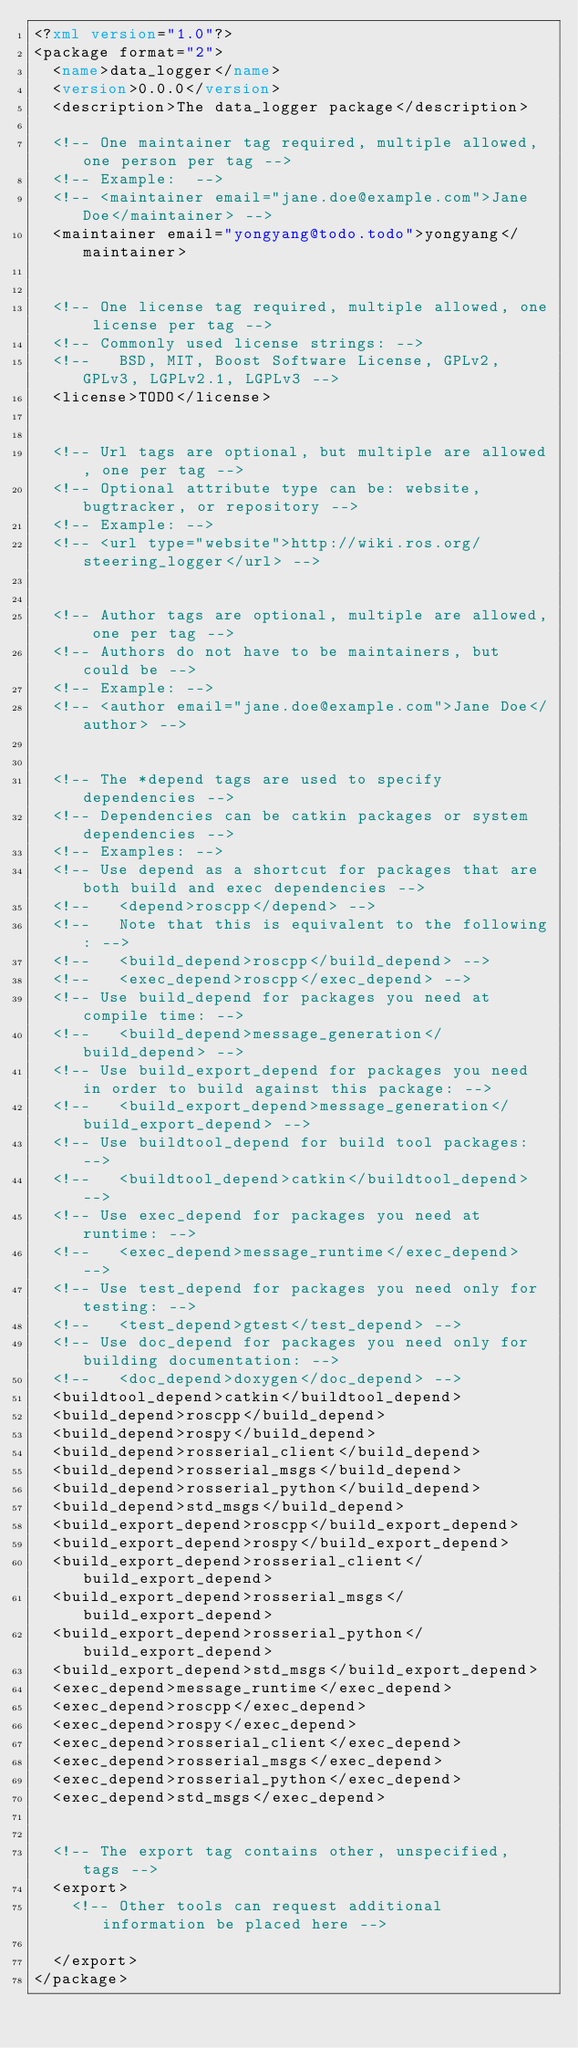<code> <loc_0><loc_0><loc_500><loc_500><_XML_><?xml version="1.0"?>
<package format="2">
  <name>data_logger</name>
  <version>0.0.0</version>
  <description>The data_logger package</description>

  <!-- One maintainer tag required, multiple allowed, one person per tag -->
  <!-- Example:  -->
  <!-- <maintainer email="jane.doe@example.com">Jane Doe</maintainer> -->
  <maintainer email="yongyang@todo.todo">yongyang</maintainer>


  <!-- One license tag required, multiple allowed, one license per tag -->
  <!-- Commonly used license strings: -->
  <!--   BSD, MIT, Boost Software License, GPLv2, GPLv3, LGPLv2.1, LGPLv3 -->
  <license>TODO</license>


  <!-- Url tags are optional, but multiple are allowed, one per tag -->
  <!-- Optional attribute type can be: website, bugtracker, or repository -->
  <!-- Example: -->
  <!-- <url type="website">http://wiki.ros.org/steering_logger</url> -->


  <!-- Author tags are optional, multiple are allowed, one per tag -->
  <!-- Authors do not have to be maintainers, but could be -->
  <!-- Example: -->
  <!-- <author email="jane.doe@example.com">Jane Doe</author> -->


  <!-- The *depend tags are used to specify dependencies -->
  <!-- Dependencies can be catkin packages or system dependencies -->
  <!-- Examples: -->
  <!-- Use depend as a shortcut for packages that are both build and exec dependencies -->
  <!--   <depend>roscpp</depend> -->
  <!--   Note that this is equivalent to the following: -->
  <!--   <build_depend>roscpp</build_depend> -->
  <!--   <exec_depend>roscpp</exec_depend> -->
  <!-- Use build_depend for packages you need at compile time: -->
  <!--   <build_depend>message_generation</build_depend> -->
  <!-- Use build_export_depend for packages you need in order to build against this package: -->
  <!--   <build_export_depend>message_generation</build_export_depend> -->
  <!-- Use buildtool_depend for build tool packages: -->
  <!--   <buildtool_depend>catkin</buildtool_depend> -->
  <!-- Use exec_depend for packages you need at runtime: -->
  <!--   <exec_depend>message_runtime</exec_depend> -->
  <!-- Use test_depend for packages you need only for testing: -->
  <!--   <test_depend>gtest</test_depend> -->
  <!-- Use doc_depend for packages you need only for building documentation: -->
  <!--   <doc_depend>doxygen</doc_depend> -->
  <buildtool_depend>catkin</buildtool_depend>
  <build_depend>roscpp</build_depend>
  <build_depend>rospy</build_depend>
  <build_depend>rosserial_client</build_depend>
  <build_depend>rosserial_msgs</build_depend>
  <build_depend>rosserial_python</build_depend>
  <build_depend>std_msgs</build_depend>
  <build_export_depend>roscpp</build_export_depend>
  <build_export_depend>rospy</build_export_depend>
  <build_export_depend>rosserial_client</build_export_depend>
  <build_export_depend>rosserial_msgs</build_export_depend>
  <build_export_depend>rosserial_python</build_export_depend>
  <build_export_depend>std_msgs</build_export_depend>
  <exec_depend>message_runtime</exec_depend>
  <exec_depend>roscpp</exec_depend>
  <exec_depend>rospy</exec_depend>
  <exec_depend>rosserial_client</exec_depend>
  <exec_depend>rosserial_msgs</exec_depend>
  <exec_depend>rosserial_python</exec_depend>
  <exec_depend>std_msgs</exec_depend>


  <!-- The export tag contains other, unspecified, tags -->
  <export>
    <!-- Other tools can request additional information be placed here -->

  </export>
</package>
</code> 